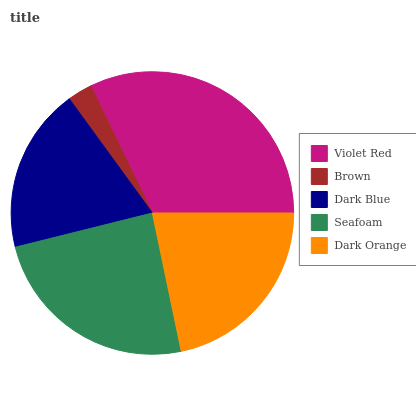Is Brown the minimum?
Answer yes or no. Yes. Is Violet Red the maximum?
Answer yes or no. Yes. Is Dark Blue the minimum?
Answer yes or no. No. Is Dark Blue the maximum?
Answer yes or no. No. Is Dark Blue greater than Brown?
Answer yes or no. Yes. Is Brown less than Dark Blue?
Answer yes or no. Yes. Is Brown greater than Dark Blue?
Answer yes or no. No. Is Dark Blue less than Brown?
Answer yes or no. No. Is Dark Orange the high median?
Answer yes or no. Yes. Is Dark Orange the low median?
Answer yes or no. Yes. Is Dark Blue the high median?
Answer yes or no. No. Is Dark Blue the low median?
Answer yes or no. No. 